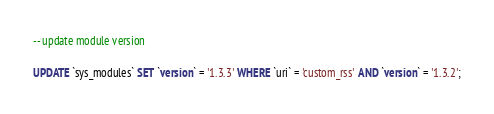Convert code to text. <code><loc_0><loc_0><loc_500><loc_500><_SQL_>

-- update module version

UPDATE `sys_modules` SET `version` = '1.3.3' WHERE `uri` = 'custom_rss' AND `version` = '1.3.2';

</code> 